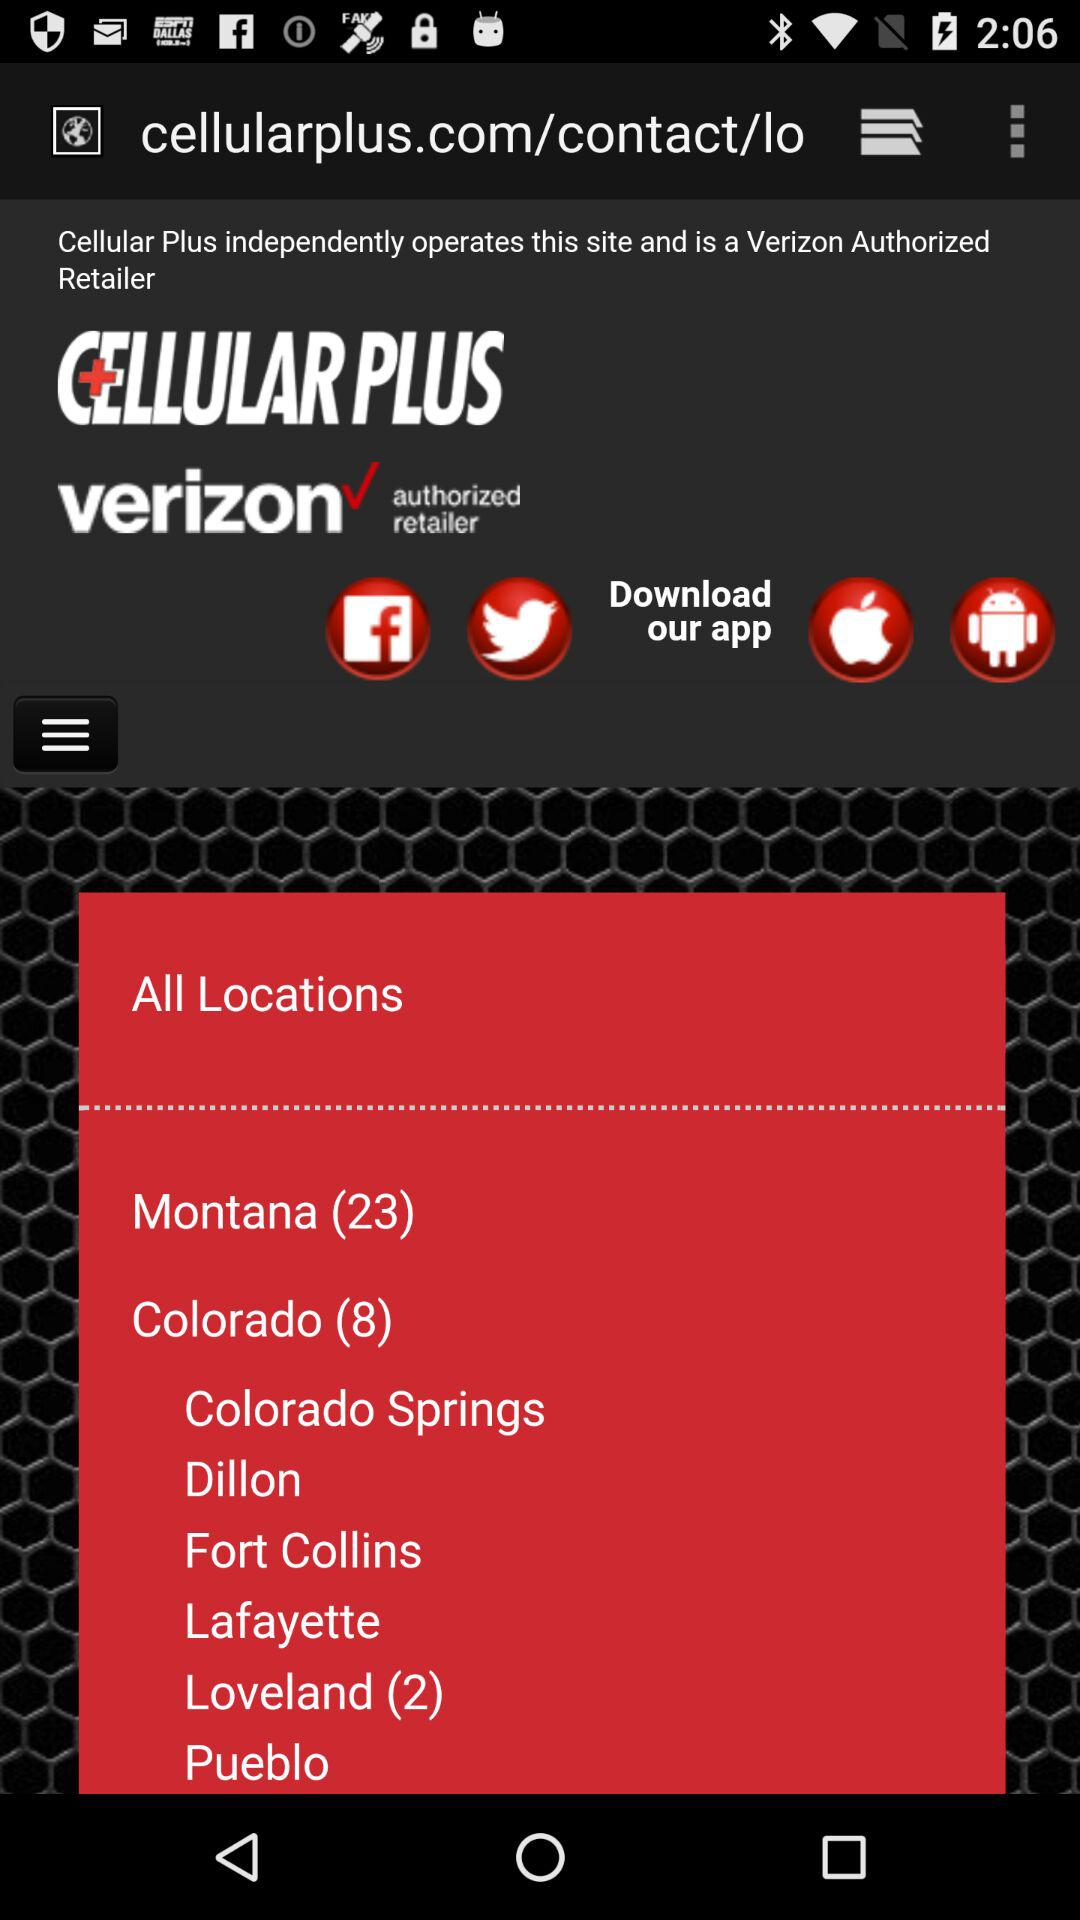What applications are used to download? The applications used to download are "Facebook", "Twitter", "Apple application", and " Android Beam". 